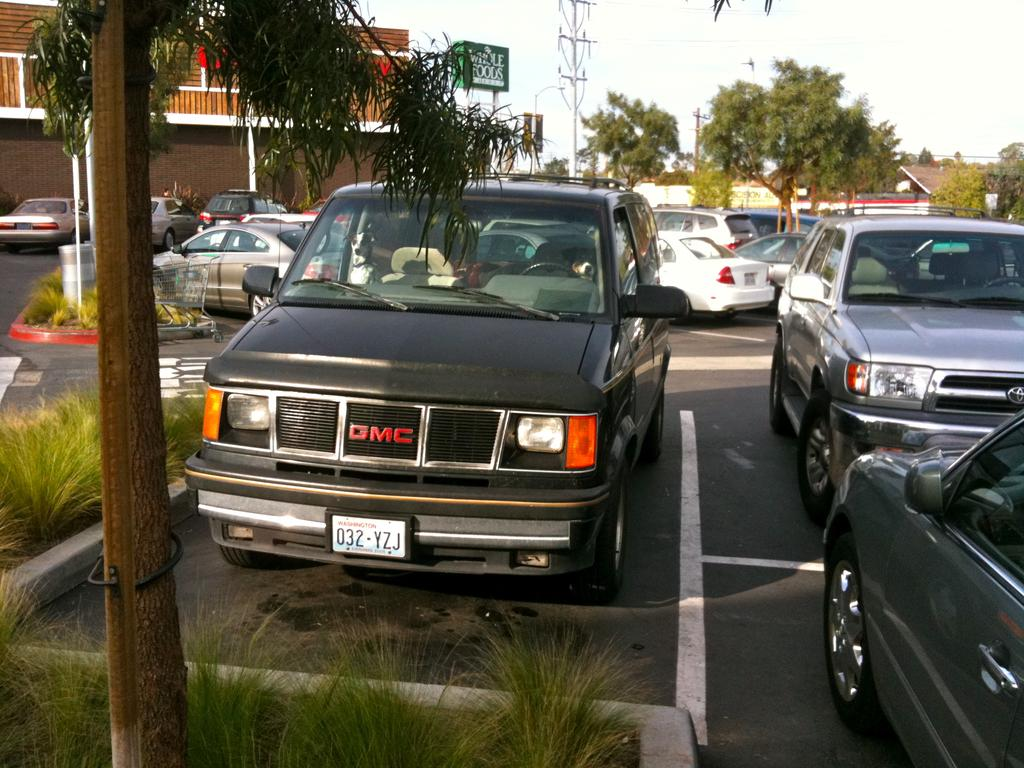What can be seen on the road in the image? There are vehicles on the road in the image. What type of vegetation is present in the image? There are plants and trees in the image. What type of structures can be seen in the image? There are buildings in the image. What is the purpose of the name board in the image? The name board in the image is likely used for identification or direction. Can you describe the objects in the image? There are some objects in the image, but their specific nature is not clear from the provided facts. What is visible in the background of the image? The sky is visible in the background of the image. How many frogs are sitting on the name board in the image? There are no frogs present in the image, so it is not possible to answer that question. 